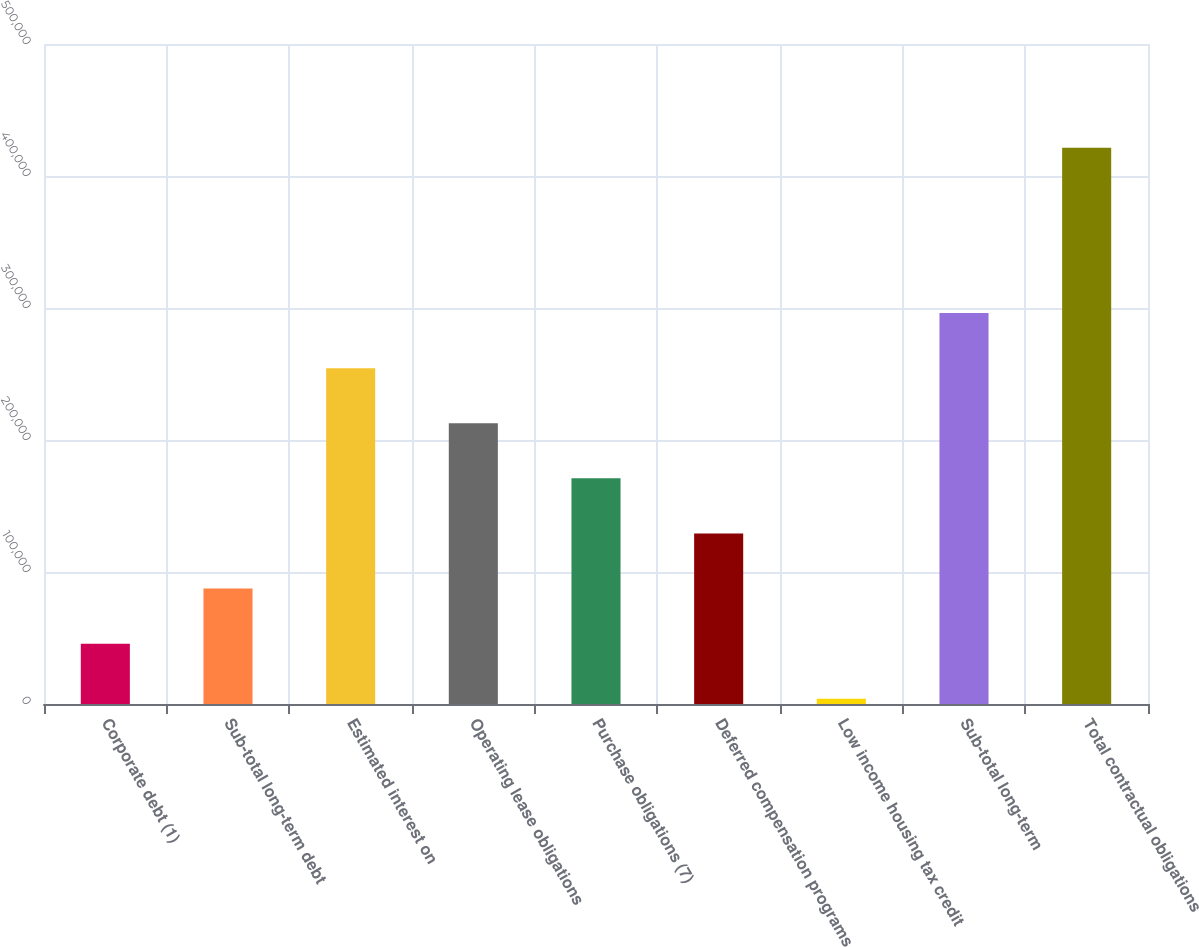<chart> <loc_0><loc_0><loc_500><loc_500><bar_chart><fcel>Corporate debt (1)<fcel>Sub-total long-term debt<fcel>Estimated interest on<fcel>Operating lease obligations<fcel>Purchase obligations (7)<fcel>Deferred compensation programs<fcel>Low income housing tax credit<fcel>Sub-total long-term<fcel>Total contractual obligations<nl><fcel>45715.3<fcel>87461.6<fcel>254447<fcel>212700<fcel>170954<fcel>129208<fcel>3969<fcel>296193<fcel>421432<nl></chart> 